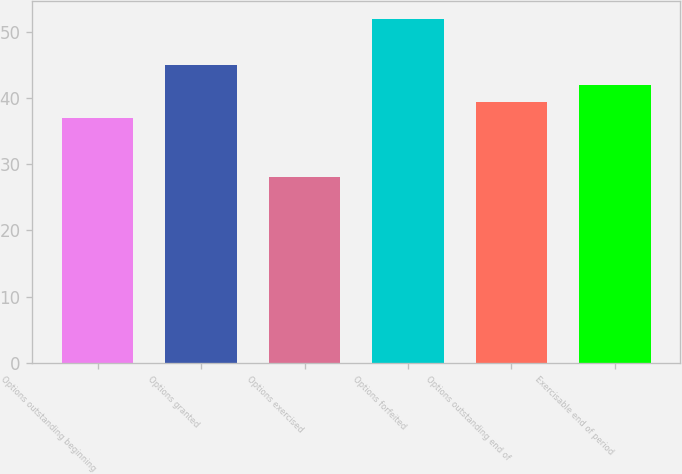Convert chart. <chart><loc_0><loc_0><loc_500><loc_500><bar_chart><fcel>Options outstanding beginning<fcel>Options granted<fcel>Options exercised<fcel>Options forfeited<fcel>Options outstanding end of<fcel>Exercisable end of period<nl><fcel>37<fcel>45<fcel>28<fcel>52<fcel>39.4<fcel>42<nl></chart> 